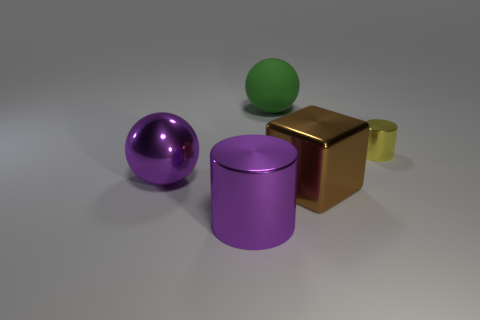Add 2 green matte balls. How many objects exist? 7 Subtract all cubes. How many objects are left? 4 Add 4 small brown cubes. How many small brown cubes exist? 4 Subtract 0 blue cylinders. How many objects are left? 5 Subtract all gray rubber balls. Subtract all big shiny blocks. How many objects are left? 4 Add 3 green things. How many green things are left? 4 